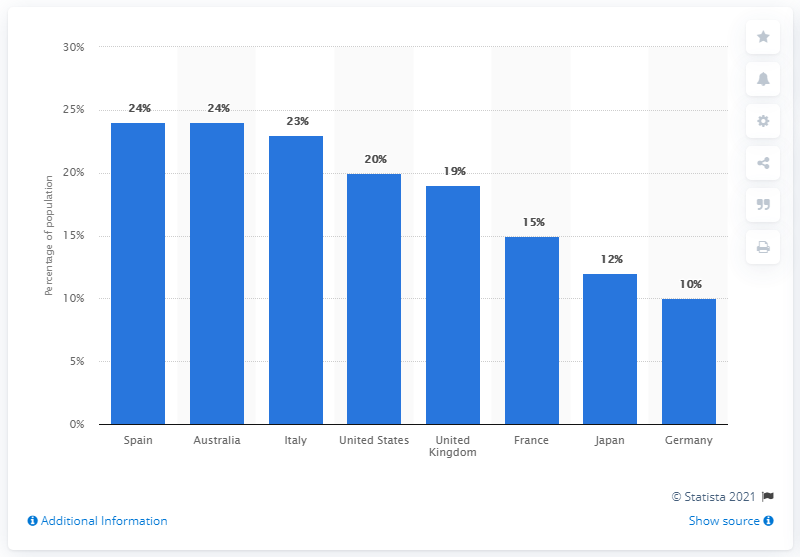Identify some key points in this picture. In the United States, approximately 20% of the population owns a tablet computer. 